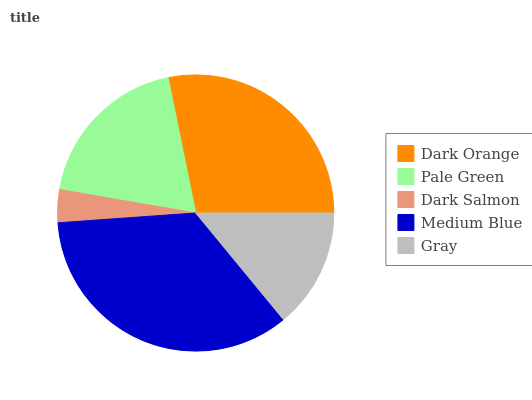Is Dark Salmon the minimum?
Answer yes or no. Yes. Is Medium Blue the maximum?
Answer yes or no. Yes. Is Pale Green the minimum?
Answer yes or no. No. Is Pale Green the maximum?
Answer yes or no. No. Is Dark Orange greater than Pale Green?
Answer yes or no. Yes. Is Pale Green less than Dark Orange?
Answer yes or no. Yes. Is Pale Green greater than Dark Orange?
Answer yes or no. No. Is Dark Orange less than Pale Green?
Answer yes or no. No. Is Pale Green the high median?
Answer yes or no. Yes. Is Pale Green the low median?
Answer yes or no. Yes. Is Medium Blue the high median?
Answer yes or no. No. Is Medium Blue the low median?
Answer yes or no. No. 